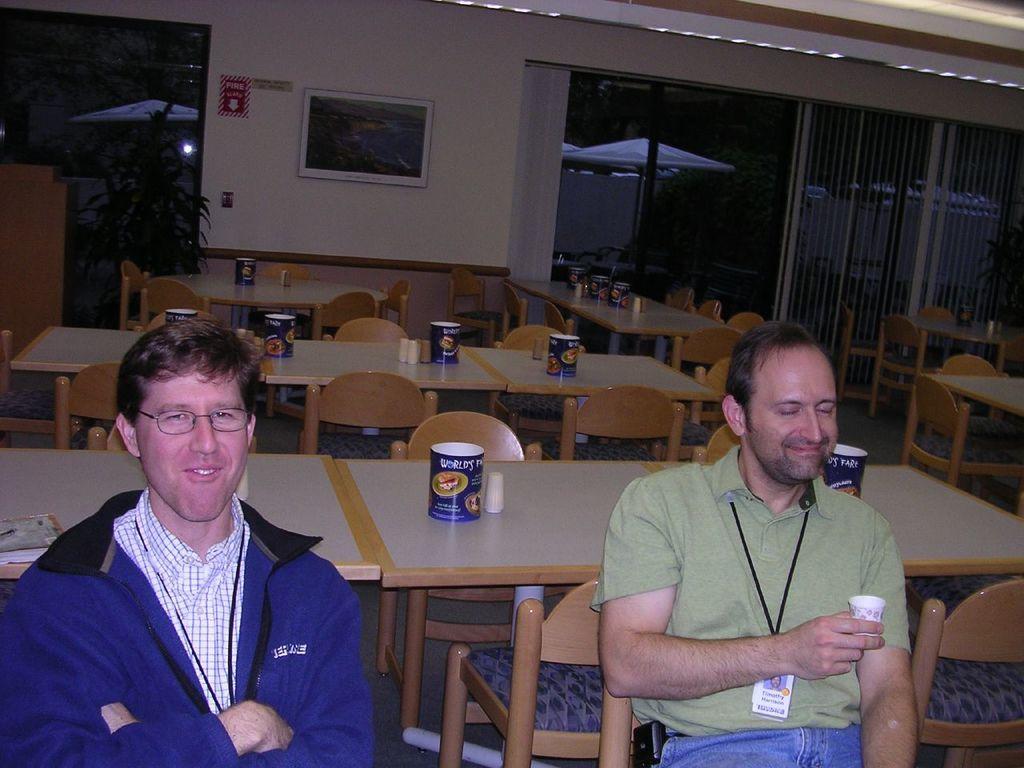How would you summarize this image in a sentence or two? 2 men are sitting in the chairs and smiling behind them there are tables chairs. 